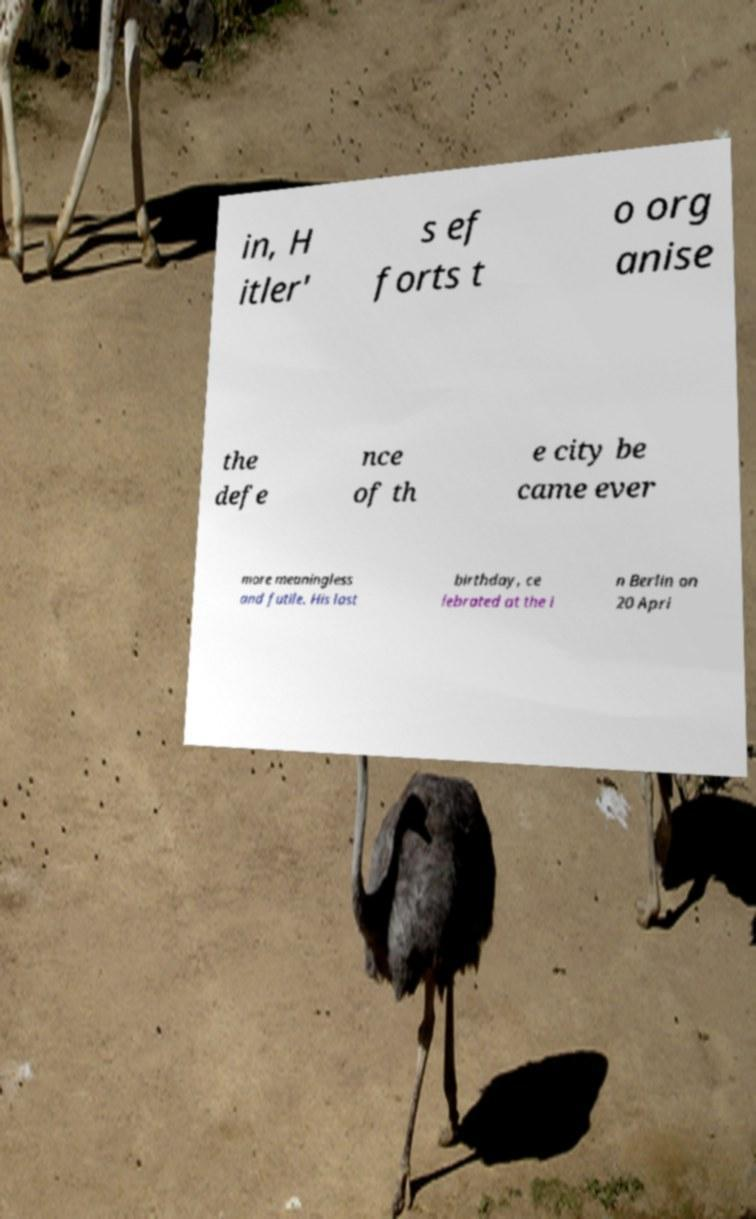Could you assist in decoding the text presented in this image and type it out clearly? in, H itler' s ef forts t o org anise the defe nce of th e city be came ever more meaningless and futile. His last birthday, ce lebrated at the i n Berlin on 20 Apri 